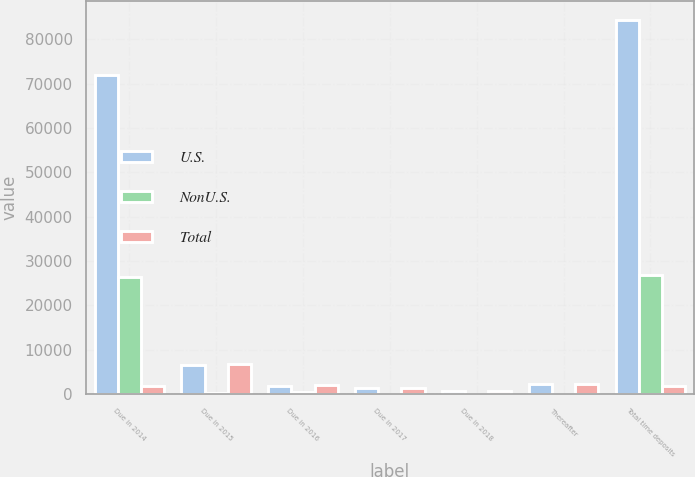Convert chart to OTSL. <chart><loc_0><loc_0><loc_500><loc_500><stacked_bar_chart><ecel><fcel>Due in 2014<fcel>Due in 2015<fcel>Due in 2016<fcel>Due in 2017<fcel>Due in 2018<fcel>Thereafter<fcel>Total time deposits<nl><fcel>U.S.<fcel>71895<fcel>6523<fcel>1719<fcel>1308<fcel>649<fcel>2274<fcel>84368<nl><fcel>NonU.S.<fcel>26306<fcel>227<fcel>315<fcel>14<fcel>1<fcel>4<fcel>26867<nl><fcel>Total<fcel>1719<fcel>6750<fcel>2034<fcel>1322<fcel>650<fcel>2278<fcel>1719<nl></chart> 